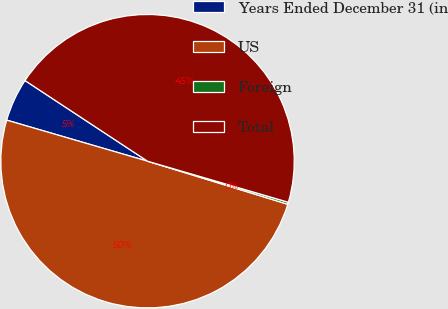Convert chart. <chart><loc_0><loc_0><loc_500><loc_500><pie_chart><fcel>Years Ended December 31 (in<fcel>US<fcel>Foreign<fcel>Total<nl><fcel>4.75%<fcel>49.77%<fcel>0.23%<fcel>45.25%<nl></chart> 